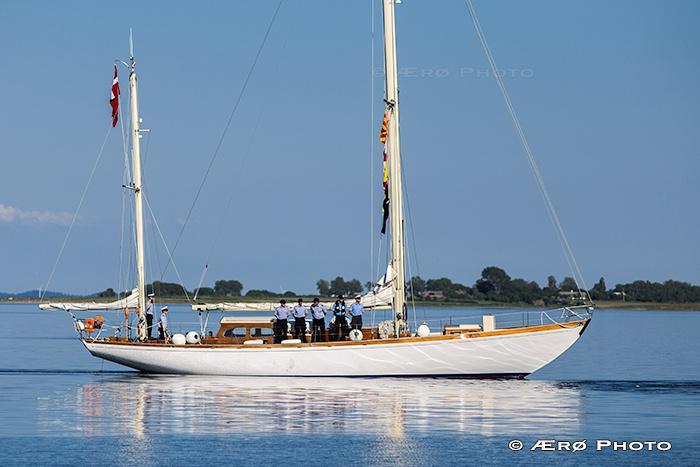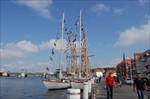The first image is the image on the left, the second image is the image on the right. Assess this claim about the two images: "there are puffy clouds in one of the images". Correct or not? Answer yes or no. Yes. The first image is the image on the left, the second image is the image on the right. Assess this claim about the two images: "Trees can be seen in the background in one  of the images.". Correct or not? Answer yes or no. Yes. 